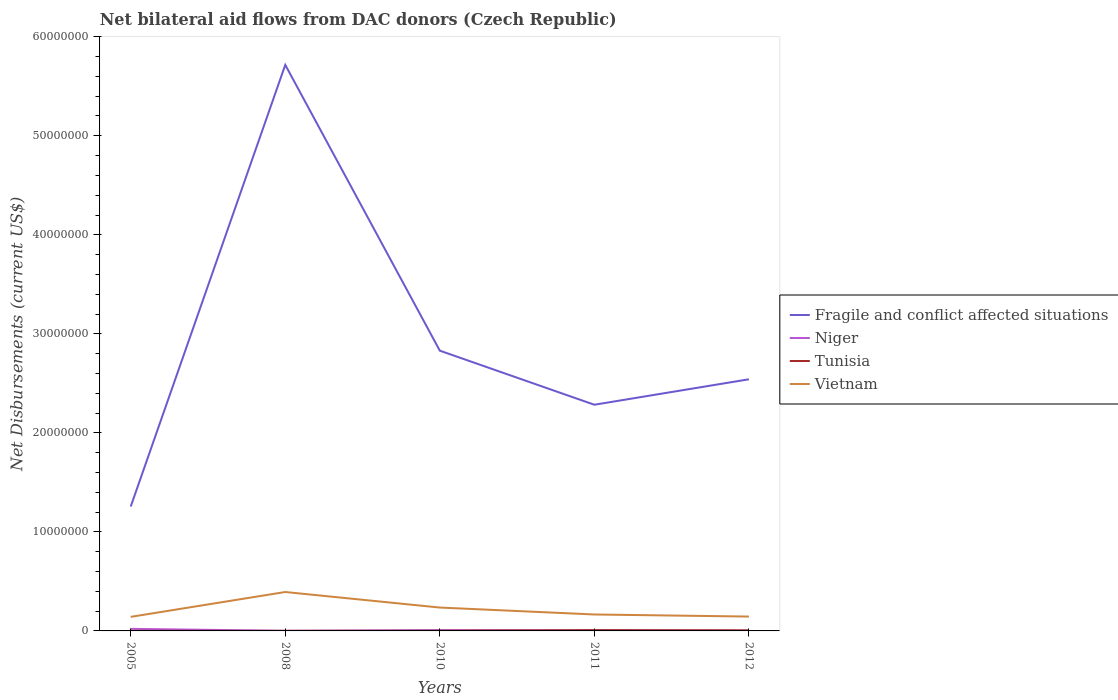How many different coloured lines are there?
Make the answer very short. 4. Is the number of lines equal to the number of legend labels?
Your response must be concise. Yes. Across all years, what is the maximum net bilateral aid flows in Fragile and conflict affected situations?
Ensure brevity in your answer.  1.26e+07. What is the total net bilateral aid flows in Vietnam in the graph?
Make the answer very short. 1.57e+06. What is the difference between the highest and the second highest net bilateral aid flows in Tunisia?
Make the answer very short. 7.00e+04. What is the difference between the highest and the lowest net bilateral aid flows in Vietnam?
Your response must be concise. 2. Is the net bilateral aid flows in Niger strictly greater than the net bilateral aid flows in Fragile and conflict affected situations over the years?
Ensure brevity in your answer.  Yes. What is the difference between two consecutive major ticks on the Y-axis?
Keep it short and to the point. 1.00e+07. Are the values on the major ticks of Y-axis written in scientific E-notation?
Make the answer very short. No. Does the graph contain any zero values?
Make the answer very short. No. Where does the legend appear in the graph?
Your answer should be compact. Center right. How many legend labels are there?
Your answer should be compact. 4. How are the legend labels stacked?
Offer a terse response. Vertical. What is the title of the graph?
Your answer should be compact. Net bilateral aid flows from DAC donors (Czech Republic). What is the label or title of the Y-axis?
Your answer should be very brief. Net Disbursements (current US$). What is the Net Disbursements (current US$) of Fragile and conflict affected situations in 2005?
Your answer should be very brief. 1.26e+07. What is the Net Disbursements (current US$) of Niger in 2005?
Give a very brief answer. 2.10e+05. What is the Net Disbursements (current US$) of Vietnam in 2005?
Your answer should be very brief. 1.42e+06. What is the Net Disbursements (current US$) of Fragile and conflict affected situations in 2008?
Give a very brief answer. 5.72e+07. What is the Net Disbursements (current US$) in Niger in 2008?
Provide a succinct answer. 10000. What is the Net Disbursements (current US$) in Vietnam in 2008?
Provide a short and direct response. 3.93e+06. What is the Net Disbursements (current US$) of Fragile and conflict affected situations in 2010?
Your response must be concise. 2.83e+07. What is the Net Disbursements (current US$) in Niger in 2010?
Keep it short and to the point. 8.00e+04. What is the Net Disbursements (current US$) of Tunisia in 2010?
Your response must be concise. 2.00e+04. What is the Net Disbursements (current US$) of Vietnam in 2010?
Your response must be concise. 2.36e+06. What is the Net Disbursements (current US$) of Fragile and conflict affected situations in 2011?
Your answer should be compact. 2.28e+07. What is the Net Disbursements (current US$) of Vietnam in 2011?
Make the answer very short. 1.66e+06. What is the Net Disbursements (current US$) in Fragile and conflict affected situations in 2012?
Keep it short and to the point. 2.54e+07. What is the Net Disbursements (current US$) of Niger in 2012?
Give a very brief answer. 2.00e+04. What is the Net Disbursements (current US$) of Tunisia in 2012?
Keep it short and to the point. 6.00e+04. What is the Net Disbursements (current US$) of Vietnam in 2012?
Provide a succinct answer. 1.45e+06. Across all years, what is the maximum Net Disbursements (current US$) of Fragile and conflict affected situations?
Ensure brevity in your answer.  5.72e+07. Across all years, what is the maximum Net Disbursements (current US$) of Vietnam?
Your answer should be compact. 3.93e+06. Across all years, what is the minimum Net Disbursements (current US$) of Fragile and conflict affected situations?
Give a very brief answer. 1.26e+07. Across all years, what is the minimum Net Disbursements (current US$) in Vietnam?
Provide a short and direct response. 1.42e+06. What is the total Net Disbursements (current US$) of Fragile and conflict affected situations in the graph?
Your response must be concise. 1.46e+08. What is the total Net Disbursements (current US$) in Vietnam in the graph?
Ensure brevity in your answer.  1.08e+07. What is the difference between the Net Disbursements (current US$) in Fragile and conflict affected situations in 2005 and that in 2008?
Offer a very short reply. -4.46e+07. What is the difference between the Net Disbursements (current US$) of Vietnam in 2005 and that in 2008?
Your answer should be compact. -2.51e+06. What is the difference between the Net Disbursements (current US$) of Fragile and conflict affected situations in 2005 and that in 2010?
Give a very brief answer. -1.57e+07. What is the difference between the Net Disbursements (current US$) of Niger in 2005 and that in 2010?
Provide a succinct answer. 1.30e+05. What is the difference between the Net Disbursements (current US$) in Vietnam in 2005 and that in 2010?
Keep it short and to the point. -9.40e+05. What is the difference between the Net Disbursements (current US$) of Fragile and conflict affected situations in 2005 and that in 2011?
Keep it short and to the point. -1.03e+07. What is the difference between the Net Disbursements (current US$) of Niger in 2005 and that in 2011?
Offer a very short reply. 1.60e+05. What is the difference between the Net Disbursements (current US$) in Fragile and conflict affected situations in 2005 and that in 2012?
Offer a very short reply. -1.28e+07. What is the difference between the Net Disbursements (current US$) of Fragile and conflict affected situations in 2008 and that in 2010?
Ensure brevity in your answer.  2.89e+07. What is the difference between the Net Disbursements (current US$) of Tunisia in 2008 and that in 2010?
Offer a terse response. -10000. What is the difference between the Net Disbursements (current US$) of Vietnam in 2008 and that in 2010?
Make the answer very short. 1.57e+06. What is the difference between the Net Disbursements (current US$) in Fragile and conflict affected situations in 2008 and that in 2011?
Your response must be concise. 3.43e+07. What is the difference between the Net Disbursements (current US$) in Niger in 2008 and that in 2011?
Provide a succinct answer. -4.00e+04. What is the difference between the Net Disbursements (current US$) of Tunisia in 2008 and that in 2011?
Your answer should be very brief. -7.00e+04. What is the difference between the Net Disbursements (current US$) of Vietnam in 2008 and that in 2011?
Ensure brevity in your answer.  2.27e+06. What is the difference between the Net Disbursements (current US$) in Fragile and conflict affected situations in 2008 and that in 2012?
Offer a very short reply. 3.18e+07. What is the difference between the Net Disbursements (current US$) of Vietnam in 2008 and that in 2012?
Ensure brevity in your answer.  2.48e+06. What is the difference between the Net Disbursements (current US$) of Fragile and conflict affected situations in 2010 and that in 2011?
Provide a succinct answer. 5.46e+06. What is the difference between the Net Disbursements (current US$) of Niger in 2010 and that in 2011?
Offer a very short reply. 3.00e+04. What is the difference between the Net Disbursements (current US$) of Tunisia in 2010 and that in 2011?
Provide a succinct answer. -6.00e+04. What is the difference between the Net Disbursements (current US$) of Vietnam in 2010 and that in 2011?
Give a very brief answer. 7.00e+05. What is the difference between the Net Disbursements (current US$) in Fragile and conflict affected situations in 2010 and that in 2012?
Your answer should be compact. 2.89e+06. What is the difference between the Net Disbursements (current US$) of Tunisia in 2010 and that in 2012?
Offer a terse response. -4.00e+04. What is the difference between the Net Disbursements (current US$) in Vietnam in 2010 and that in 2012?
Give a very brief answer. 9.10e+05. What is the difference between the Net Disbursements (current US$) of Fragile and conflict affected situations in 2011 and that in 2012?
Offer a terse response. -2.57e+06. What is the difference between the Net Disbursements (current US$) in Tunisia in 2011 and that in 2012?
Make the answer very short. 2.00e+04. What is the difference between the Net Disbursements (current US$) of Fragile and conflict affected situations in 2005 and the Net Disbursements (current US$) of Niger in 2008?
Keep it short and to the point. 1.26e+07. What is the difference between the Net Disbursements (current US$) in Fragile and conflict affected situations in 2005 and the Net Disbursements (current US$) in Tunisia in 2008?
Provide a succinct answer. 1.26e+07. What is the difference between the Net Disbursements (current US$) of Fragile and conflict affected situations in 2005 and the Net Disbursements (current US$) of Vietnam in 2008?
Give a very brief answer. 8.63e+06. What is the difference between the Net Disbursements (current US$) in Niger in 2005 and the Net Disbursements (current US$) in Tunisia in 2008?
Your answer should be compact. 2.00e+05. What is the difference between the Net Disbursements (current US$) in Niger in 2005 and the Net Disbursements (current US$) in Vietnam in 2008?
Your answer should be very brief. -3.72e+06. What is the difference between the Net Disbursements (current US$) in Tunisia in 2005 and the Net Disbursements (current US$) in Vietnam in 2008?
Provide a succinct answer. -3.92e+06. What is the difference between the Net Disbursements (current US$) in Fragile and conflict affected situations in 2005 and the Net Disbursements (current US$) in Niger in 2010?
Provide a short and direct response. 1.25e+07. What is the difference between the Net Disbursements (current US$) of Fragile and conflict affected situations in 2005 and the Net Disbursements (current US$) of Tunisia in 2010?
Provide a short and direct response. 1.25e+07. What is the difference between the Net Disbursements (current US$) of Fragile and conflict affected situations in 2005 and the Net Disbursements (current US$) of Vietnam in 2010?
Keep it short and to the point. 1.02e+07. What is the difference between the Net Disbursements (current US$) in Niger in 2005 and the Net Disbursements (current US$) in Vietnam in 2010?
Make the answer very short. -2.15e+06. What is the difference between the Net Disbursements (current US$) in Tunisia in 2005 and the Net Disbursements (current US$) in Vietnam in 2010?
Make the answer very short. -2.35e+06. What is the difference between the Net Disbursements (current US$) of Fragile and conflict affected situations in 2005 and the Net Disbursements (current US$) of Niger in 2011?
Make the answer very short. 1.25e+07. What is the difference between the Net Disbursements (current US$) in Fragile and conflict affected situations in 2005 and the Net Disbursements (current US$) in Tunisia in 2011?
Ensure brevity in your answer.  1.25e+07. What is the difference between the Net Disbursements (current US$) in Fragile and conflict affected situations in 2005 and the Net Disbursements (current US$) in Vietnam in 2011?
Your response must be concise. 1.09e+07. What is the difference between the Net Disbursements (current US$) of Niger in 2005 and the Net Disbursements (current US$) of Vietnam in 2011?
Offer a terse response. -1.45e+06. What is the difference between the Net Disbursements (current US$) in Tunisia in 2005 and the Net Disbursements (current US$) in Vietnam in 2011?
Offer a terse response. -1.65e+06. What is the difference between the Net Disbursements (current US$) in Fragile and conflict affected situations in 2005 and the Net Disbursements (current US$) in Niger in 2012?
Give a very brief answer. 1.25e+07. What is the difference between the Net Disbursements (current US$) in Fragile and conflict affected situations in 2005 and the Net Disbursements (current US$) in Tunisia in 2012?
Provide a succinct answer. 1.25e+07. What is the difference between the Net Disbursements (current US$) of Fragile and conflict affected situations in 2005 and the Net Disbursements (current US$) of Vietnam in 2012?
Offer a terse response. 1.11e+07. What is the difference between the Net Disbursements (current US$) of Niger in 2005 and the Net Disbursements (current US$) of Vietnam in 2012?
Provide a short and direct response. -1.24e+06. What is the difference between the Net Disbursements (current US$) in Tunisia in 2005 and the Net Disbursements (current US$) in Vietnam in 2012?
Keep it short and to the point. -1.44e+06. What is the difference between the Net Disbursements (current US$) in Fragile and conflict affected situations in 2008 and the Net Disbursements (current US$) in Niger in 2010?
Give a very brief answer. 5.71e+07. What is the difference between the Net Disbursements (current US$) in Fragile and conflict affected situations in 2008 and the Net Disbursements (current US$) in Tunisia in 2010?
Offer a very short reply. 5.71e+07. What is the difference between the Net Disbursements (current US$) of Fragile and conflict affected situations in 2008 and the Net Disbursements (current US$) of Vietnam in 2010?
Provide a short and direct response. 5.48e+07. What is the difference between the Net Disbursements (current US$) in Niger in 2008 and the Net Disbursements (current US$) in Vietnam in 2010?
Your answer should be compact. -2.35e+06. What is the difference between the Net Disbursements (current US$) of Tunisia in 2008 and the Net Disbursements (current US$) of Vietnam in 2010?
Keep it short and to the point. -2.35e+06. What is the difference between the Net Disbursements (current US$) of Fragile and conflict affected situations in 2008 and the Net Disbursements (current US$) of Niger in 2011?
Ensure brevity in your answer.  5.71e+07. What is the difference between the Net Disbursements (current US$) of Fragile and conflict affected situations in 2008 and the Net Disbursements (current US$) of Tunisia in 2011?
Ensure brevity in your answer.  5.71e+07. What is the difference between the Net Disbursements (current US$) of Fragile and conflict affected situations in 2008 and the Net Disbursements (current US$) of Vietnam in 2011?
Your answer should be very brief. 5.55e+07. What is the difference between the Net Disbursements (current US$) in Niger in 2008 and the Net Disbursements (current US$) in Vietnam in 2011?
Ensure brevity in your answer.  -1.65e+06. What is the difference between the Net Disbursements (current US$) of Tunisia in 2008 and the Net Disbursements (current US$) of Vietnam in 2011?
Give a very brief answer. -1.65e+06. What is the difference between the Net Disbursements (current US$) of Fragile and conflict affected situations in 2008 and the Net Disbursements (current US$) of Niger in 2012?
Make the answer very short. 5.71e+07. What is the difference between the Net Disbursements (current US$) of Fragile and conflict affected situations in 2008 and the Net Disbursements (current US$) of Tunisia in 2012?
Offer a very short reply. 5.71e+07. What is the difference between the Net Disbursements (current US$) of Fragile and conflict affected situations in 2008 and the Net Disbursements (current US$) of Vietnam in 2012?
Your answer should be very brief. 5.57e+07. What is the difference between the Net Disbursements (current US$) of Niger in 2008 and the Net Disbursements (current US$) of Vietnam in 2012?
Provide a short and direct response. -1.44e+06. What is the difference between the Net Disbursements (current US$) in Tunisia in 2008 and the Net Disbursements (current US$) in Vietnam in 2012?
Offer a very short reply. -1.44e+06. What is the difference between the Net Disbursements (current US$) in Fragile and conflict affected situations in 2010 and the Net Disbursements (current US$) in Niger in 2011?
Make the answer very short. 2.82e+07. What is the difference between the Net Disbursements (current US$) of Fragile and conflict affected situations in 2010 and the Net Disbursements (current US$) of Tunisia in 2011?
Your answer should be compact. 2.82e+07. What is the difference between the Net Disbursements (current US$) of Fragile and conflict affected situations in 2010 and the Net Disbursements (current US$) of Vietnam in 2011?
Your answer should be very brief. 2.66e+07. What is the difference between the Net Disbursements (current US$) in Niger in 2010 and the Net Disbursements (current US$) in Tunisia in 2011?
Provide a short and direct response. 0. What is the difference between the Net Disbursements (current US$) of Niger in 2010 and the Net Disbursements (current US$) of Vietnam in 2011?
Your answer should be compact. -1.58e+06. What is the difference between the Net Disbursements (current US$) of Tunisia in 2010 and the Net Disbursements (current US$) of Vietnam in 2011?
Provide a succinct answer. -1.64e+06. What is the difference between the Net Disbursements (current US$) of Fragile and conflict affected situations in 2010 and the Net Disbursements (current US$) of Niger in 2012?
Offer a terse response. 2.83e+07. What is the difference between the Net Disbursements (current US$) of Fragile and conflict affected situations in 2010 and the Net Disbursements (current US$) of Tunisia in 2012?
Provide a short and direct response. 2.82e+07. What is the difference between the Net Disbursements (current US$) of Fragile and conflict affected situations in 2010 and the Net Disbursements (current US$) of Vietnam in 2012?
Ensure brevity in your answer.  2.68e+07. What is the difference between the Net Disbursements (current US$) in Niger in 2010 and the Net Disbursements (current US$) in Vietnam in 2012?
Offer a very short reply. -1.37e+06. What is the difference between the Net Disbursements (current US$) of Tunisia in 2010 and the Net Disbursements (current US$) of Vietnam in 2012?
Keep it short and to the point. -1.43e+06. What is the difference between the Net Disbursements (current US$) of Fragile and conflict affected situations in 2011 and the Net Disbursements (current US$) of Niger in 2012?
Provide a short and direct response. 2.28e+07. What is the difference between the Net Disbursements (current US$) of Fragile and conflict affected situations in 2011 and the Net Disbursements (current US$) of Tunisia in 2012?
Offer a terse response. 2.28e+07. What is the difference between the Net Disbursements (current US$) of Fragile and conflict affected situations in 2011 and the Net Disbursements (current US$) of Vietnam in 2012?
Offer a terse response. 2.14e+07. What is the difference between the Net Disbursements (current US$) of Niger in 2011 and the Net Disbursements (current US$) of Vietnam in 2012?
Provide a short and direct response. -1.40e+06. What is the difference between the Net Disbursements (current US$) of Tunisia in 2011 and the Net Disbursements (current US$) of Vietnam in 2012?
Your response must be concise. -1.37e+06. What is the average Net Disbursements (current US$) of Fragile and conflict affected situations per year?
Your response must be concise. 2.93e+07. What is the average Net Disbursements (current US$) in Niger per year?
Provide a succinct answer. 7.40e+04. What is the average Net Disbursements (current US$) in Tunisia per year?
Ensure brevity in your answer.  3.60e+04. What is the average Net Disbursements (current US$) of Vietnam per year?
Your answer should be very brief. 2.16e+06. In the year 2005, what is the difference between the Net Disbursements (current US$) in Fragile and conflict affected situations and Net Disbursements (current US$) in Niger?
Provide a succinct answer. 1.24e+07. In the year 2005, what is the difference between the Net Disbursements (current US$) of Fragile and conflict affected situations and Net Disbursements (current US$) of Tunisia?
Give a very brief answer. 1.26e+07. In the year 2005, what is the difference between the Net Disbursements (current US$) of Fragile and conflict affected situations and Net Disbursements (current US$) of Vietnam?
Provide a short and direct response. 1.11e+07. In the year 2005, what is the difference between the Net Disbursements (current US$) in Niger and Net Disbursements (current US$) in Vietnam?
Provide a succinct answer. -1.21e+06. In the year 2005, what is the difference between the Net Disbursements (current US$) of Tunisia and Net Disbursements (current US$) of Vietnam?
Your answer should be compact. -1.41e+06. In the year 2008, what is the difference between the Net Disbursements (current US$) in Fragile and conflict affected situations and Net Disbursements (current US$) in Niger?
Your answer should be compact. 5.72e+07. In the year 2008, what is the difference between the Net Disbursements (current US$) in Fragile and conflict affected situations and Net Disbursements (current US$) in Tunisia?
Offer a terse response. 5.72e+07. In the year 2008, what is the difference between the Net Disbursements (current US$) of Fragile and conflict affected situations and Net Disbursements (current US$) of Vietnam?
Provide a short and direct response. 5.32e+07. In the year 2008, what is the difference between the Net Disbursements (current US$) of Niger and Net Disbursements (current US$) of Vietnam?
Your answer should be compact. -3.92e+06. In the year 2008, what is the difference between the Net Disbursements (current US$) of Tunisia and Net Disbursements (current US$) of Vietnam?
Offer a very short reply. -3.92e+06. In the year 2010, what is the difference between the Net Disbursements (current US$) of Fragile and conflict affected situations and Net Disbursements (current US$) of Niger?
Your response must be concise. 2.82e+07. In the year 2010, what is the difference between the Net Disbursements (current US$) of Fragile and conflict affected situations and Net Disbursements (current US$) of Tunisia?
Your response must be concise. 2.83e+07. In the year 2010, what is the difference between the Net Disbursements (current US$) of Fragile and conflict affected situations and Net Disbursements (current US$) of Vietnam?
Provide a succinct answer. 2.59e+07. In the year 2010, what is the difference between the Net Disbursements (current US$) in Niger and Net Disbursements (current US$) in Tunisia?
Provide a succinct answer. 6.00e+04. In the year 2010, what is the difference between the Net Disbursements (current US$) of Niger and Net Disbursements (current US$) of Vietnam?
Offer a very short reply. -2.28e+06. In the year 2010, what is the difference between the Net Disbursements (current US$) in Tunisia and Net Disbursements (current US$) in Vietnam?
Ensure brevity in your answer.  -2.34e+06. In the year 2011, what is the difference between the Net Disbursements (current US$) of Fragile and conflict affected situations and Net Disbursements (current US$) of Niger?
Give a very brief answer. 2.28e+07. In the year 2011, what is the difference between the Net Disbursements (current US$) of Fragile and conflict affected situations and Net Disbursements (current US$) of Tunisia?
Provide a succinct answer. 2.28e+07. In the year 2011, what is the difference between the Net Disbursements (current US$) of Fragile and conflict affected situations and Net Disbursements (current US$) of Vietnam?
Your answer should be compact. 2.12e+07. In the year 2011, what is the difference between the Net Disbursements (current US$) in Niger and Net Disbursements (current US$) in Tunisia?
Provide a succinct answer. -3.00e+04. In the year 2011, what is the difference between the Net Disbursements (current US$) in Niger and Net Disbursements (current US$) in Vietnam?
Ensure brevity in your answer.  -1.61e+06. In the year 2011, what is the difference between the Net Disbursements (current US$) of Tunisia and Net Disbursements (current US$) of Vietnam?
Provide a short and direct response. -1.58e+06. In the year 2012, what is the difference between the Net Disbursements (current US$) of Fragile and conflict affected situations and Net Disbursements (current US$) of Niger?
Your response must be concise. 2.54e+07. In the year 2012, what is the difference between the Net Disbursements (current US$) of Fragile and conflict affected situations and Net Disbursements (current US$) of Tunisia?
Offer a very short reply. 2.54e+07. In the year 2012, what is the difference between the Net Disbursements (current US$) of Fragile and conflict affected situations and Net Disbursements (current US$) of Vietnam?
Offer a terse response. 2.40e+07. In the year 2012, what is the difference between the Net Disbursements (current US$) of Niger and Net Disbursements (current US$) of Tunisia?
Keep it short and to the point. -4.00e+04. In the year 2012, what is the difference between the Net Disbursements (current US$) in Niger and Net Disbursements (current US$) in Vietnam?
Provide a succinct answer. -1.43e+06. In the year 2012, what is the difference between the Net Disbursements (current US$) in Tunisia and Net Disbursements (current US$) in Vietnam?
Provide a succinct answer. -1.39e+06. What is the ratio of the Net Disbursements (current US$) in Fragile and conflict affected situations in 2005 to that in 2008?
Provide a succinct answer. 0.22. What is the ratio of the Net Disbursements (current US$) in Tunisia in 2005 to that in 2008?
Your answer should be compact. 1. What is the ratio of the Net Disbursements (current US$) of Vietnam in 2005 to that in 2008?
Your response must be concise. 0.36. What is the ratio of the Net Disbursements (current US$) of Fragile and conflict affected situations in 2005 to that in 2010?
Your answer should be compact. 0.44. What is the ratio of the Net Disbursements (current US$) of Niger in 2005 to that in 2010?
Provide a short and direct response. 2.62. What is the ratio of the Net Disbursements (current US$) in Vietnam in 2005 to that in 2010?
Offer a terse response. 0.6. What is the ratio of the Net Disbursements (current US$) in Fragile and conflict affected situations in 2005 to that in 2011?
Provide a succinct answer. 0.55. What is the ratio of the Net Disbursements (current US$) in Vietnam in 2005 to that in 2011?
Ensure brevity in your answer.  0.86. What is the ratio of the Net Disbursements (current US$) of Fragile and conflict affected situations in 2005 to that in 2012?
Provide a short and direct response. 0.49. What is the ratio of the Net Disbursements (current US$) of Vietnam in 2005 to that in 2012?
Give a very brief answer. 0.98. What is the ratio of the Net Disbursements (current US$) of Fragile and conflict affected situations in 2008 to that in 2010?
Provide a short and direct response. 2.02. What is the ratio of the Net Disbursements (current US$) of Tunisia in 2008 to that in 2010?
Your answer should be very brief. 0.5. What is the ratio of the Net Disbursements (current US$) of Vietnam in 2008 to that in 2010?
Your answer should be very brief. 1.67. What is the ratio of the Net Disbursements (current US$) in Fragile and conflict affected situations in 2008 to that in 2011?
Make the answer very short. 2.5. What is the ratio of the Net Disbursements (current US$) in Vietnam in 2008 to that in 2011?
Offer a very short reply. 2.37. What is the ratio of the Net Disbursements (current US$) in Fragile and conflict affected situations in 2008 to that in 2012?
Your answer should be very brief. 2.25. What is the ratio of the Net Disbursements (current US$) of Tunisia in 2008 to that in 2012?
Keep it short and to the point. 0.17. What is the ratio of the Net Disbursements (current US$) of Vietnam in 2008 to that in 2012?
Offer a terse response. 2.71. What is the ratio of the Net Disbursements (current US$) in Fragile and conflict affected situations in 2010 to that in 2011?
Offer a terse response. 1.24. What is the ratio of the Net Disbursements (current US$) in Tunisia in 2010 to that in 2011?
Keep it short and to the point. 0.25. What is the ratio of the Net Disbursements (current US$) in Vietnam in 2010 to that in 2011?
Make the answer very short. 1.42. What is the ratio of the Net Disbursements (current US$) in Fragile and conflict affected situations in 2010 to that in 2012?
Provide a short and direct response. 1.11. What is the ratio of the Net Disbursements (current US$) of Niger in 2010 to that in 2012?
Ensure brevity in your answer.  4. What is the ratio of the Net Disbursements (current US$) in Vietnam in 2010 to that in 2012?
Offer a terse response. 1.63. What is the ratio of the Net Disbursements (current US$) of Fragile and conflict affected situations in 2011 to that in 2012?
Your answer should be very brief. 0.9. What is the ratio of the Net Disbursements (current US$) in Niger in 2011 to that in 2012?
Keep it short and to the point. 2.5. What is the ratio of the Net Disbursements (current US$) in Tunisia in 2011 to that in 2012?
Ensure brevity in your answer.  1.33. What is the ratio of the Net Disbursements (current US$) of Vietnam in 2011 to that in 2012?
Keep it short and to the point. 1.14. What is the difference between the highest and the second highest Net Disbursements (current US$) of Fragile and conflict affected situations?
Offer a terse response. 2.89e+07. What is the difference between the highest and the second highest Net Disbursements (current US$) of Tunisia?
Keep it short and to the point. 2.00e+04. What is the difference between the highest and the second highest Net Disbursements (current US$) of Vietnam?
Your answer should be compact. 1.57e+06. What is the difference between the highest and the lowest Net Disbursements (current US$) of Fragile and conflict affected situations?
Your answer should be very brief. 4.46e+07. What is the difference between the highest and the lowest Net Disbursements (current US$) of Niger?
Your response must be concise. 2.00e+05. What is the difference between the highest and the lowest Net Disbursements (current US$) of Tunisia?
Provide a succinct answer. 7.00e+04. What is the difference between the highest and the lowest Net Disbursements (current US$) in Vietnam?
Provide a short and direct response. 2.51e+06. 